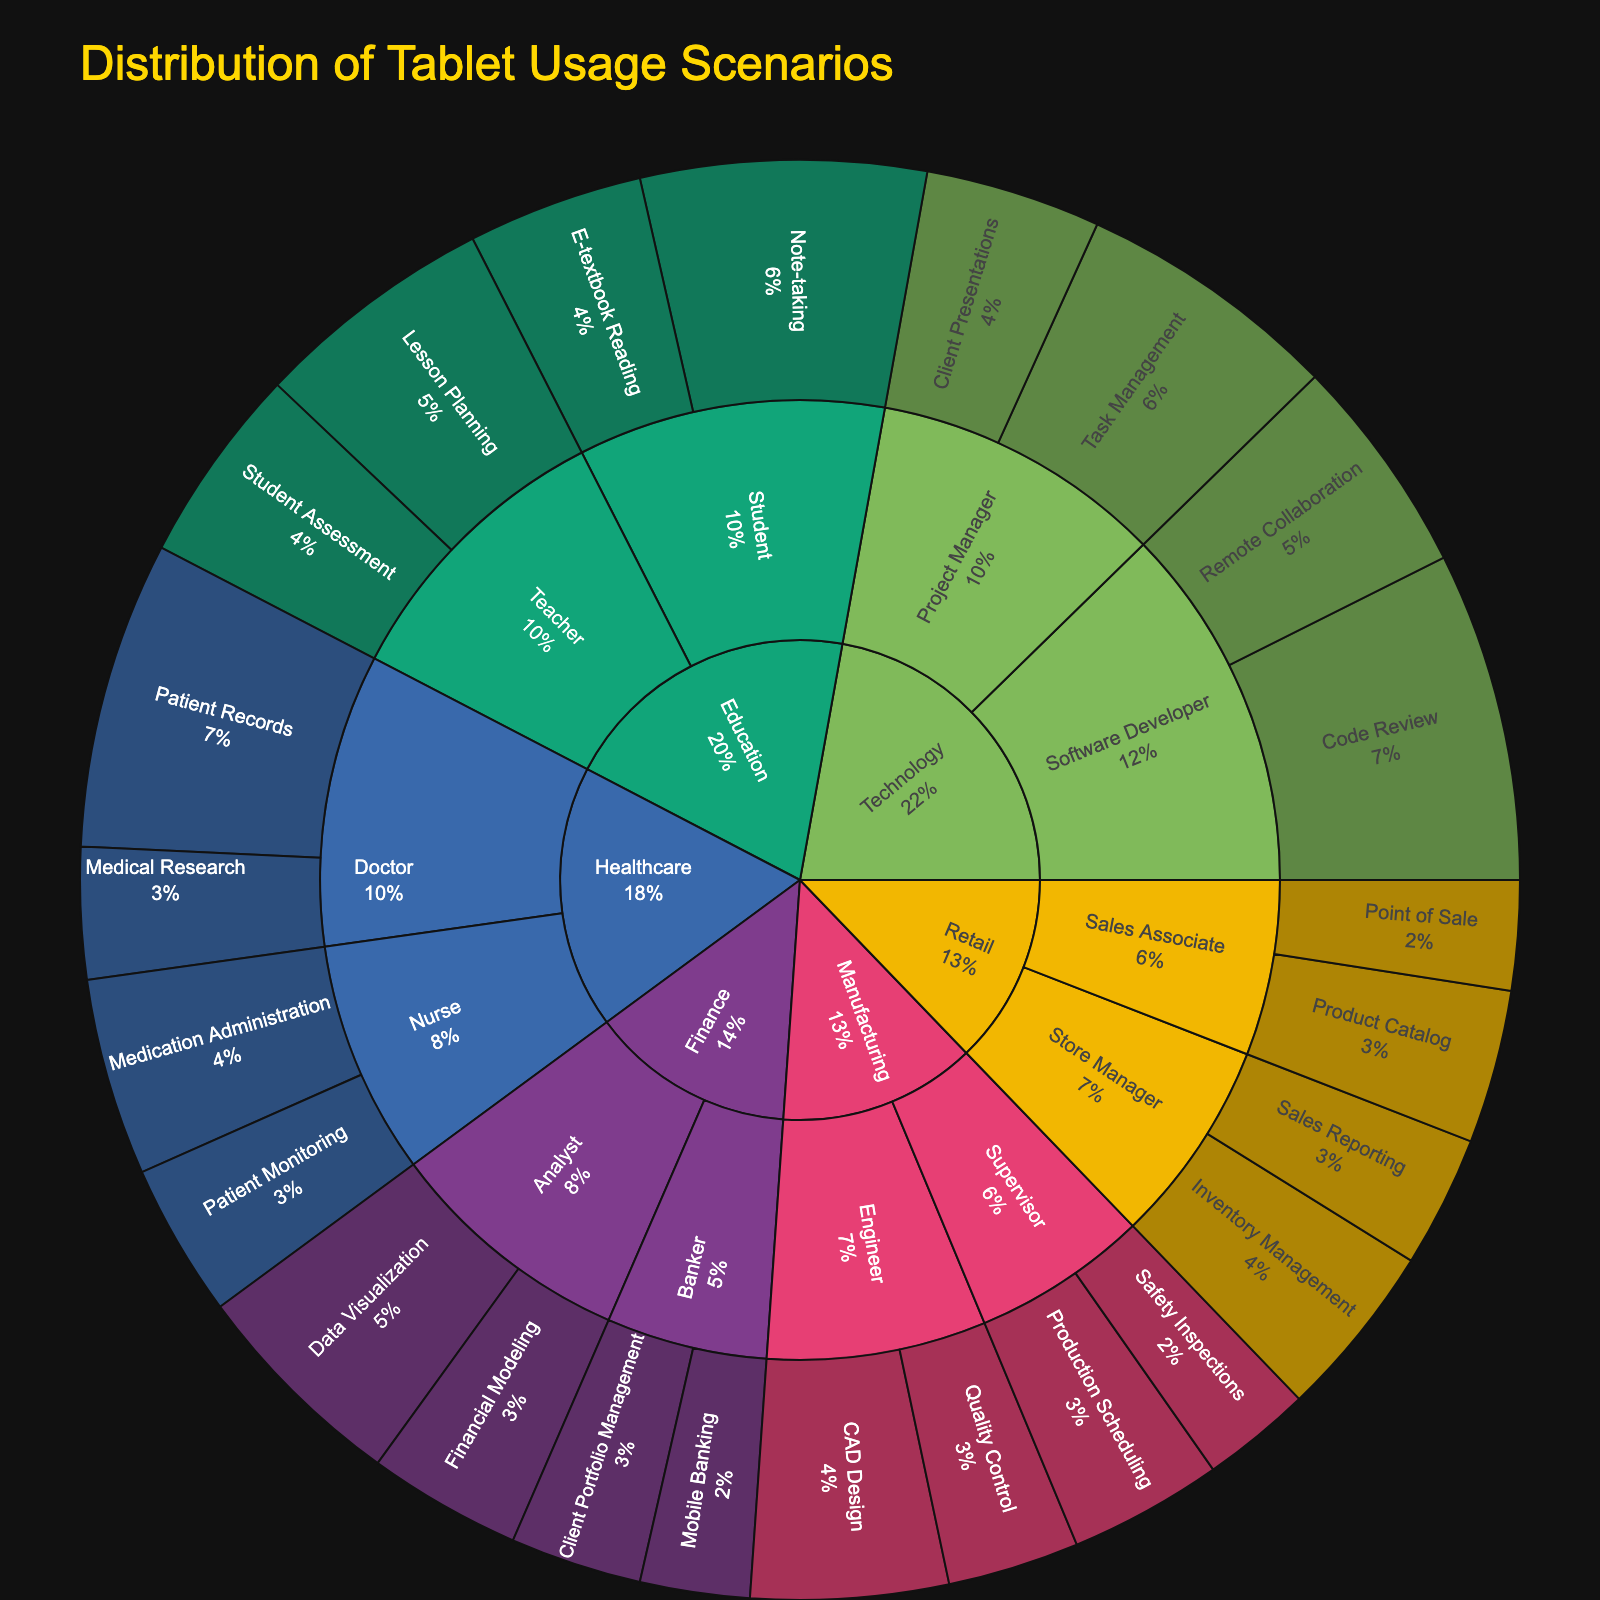What is the title of the figure? The title is usually in a larger and often bold font, found typically at the top of the figure. In this case, the title is stated as a part of the data used to generate the plot.
Answer: Distribution of Tablet Usage Scenarios Which industry has the highest percentage usage in a single role-scenario combination? By examining the individual segments of the sunburst plot and locating their percentages, the Technology industry, Software Developer role for Code Review has 15%, which is the highest.
Answer: Technology, Software Developer, Code Review What is the combined percentage of tablet usage by Project Managers in the Technology industry? Add the percentage for Task Management (12%) and Client Presentations (8%). 12% + 8% = 20%
Answer: 20% How does tablet usage for Patient Records compare to Note-taking among Students? Locate and identify the segments representing tablet usage for Patient Records in Healthcare (14%) and Note-taking among Students in Education (13%) and compare them.
Answer: Patient Records is higher What industry has the widest variety of usage scenarios? Look for the industry with the most unique job roles and scenarios branching out from it. Healthcare and Education have several roles and scenarios, but Technology has the most variety with Software Developer and Project Manager covering multiple scenarios.
Answer: Technology What is the percentage difference between tablet usage in Mobile Banking by Bankers and in Sales Reporting by Store Managers? Find the segments for Mobile Banking by Bankers (5%) and Sales Reporting by Store Managers (6%), then compute the difference: 6% - 5% = 1%
Answer: 1% What is the main usage scenario for tablets within the Finance industry? Identify the largest single segment within the Finance industry on the plot. Data Visualization by Analysts has 10%, which is the highest in Finance.
Answer: Data Visualization How does the usage of tablets for CAD Design in Manufacturing compare to Task Management in Technology? Identify the percentages of CAD Design by Engineers in Manufacturing (9%) and Task Management by Project Managers in Technology (12%), then determine their comparison.
Answer: Task Management is higher What percentage of total tablet usage scenarios fall under Education? Sum up the relevant percentages: Lesson Planning (11%), Student Assessment (9%), Note-taking (13%), E-textbook Reading (8%). The total is 11% + 9% + 13% + 8% = 41%
Answer: 41% How many job roles in total use tablets for Inventory Management? Count the occurrences of the Inventory Management scenario appearing in the sunburst segments. Retail Store Managers are the only job roles using tablets for this task.
Answer: 1 